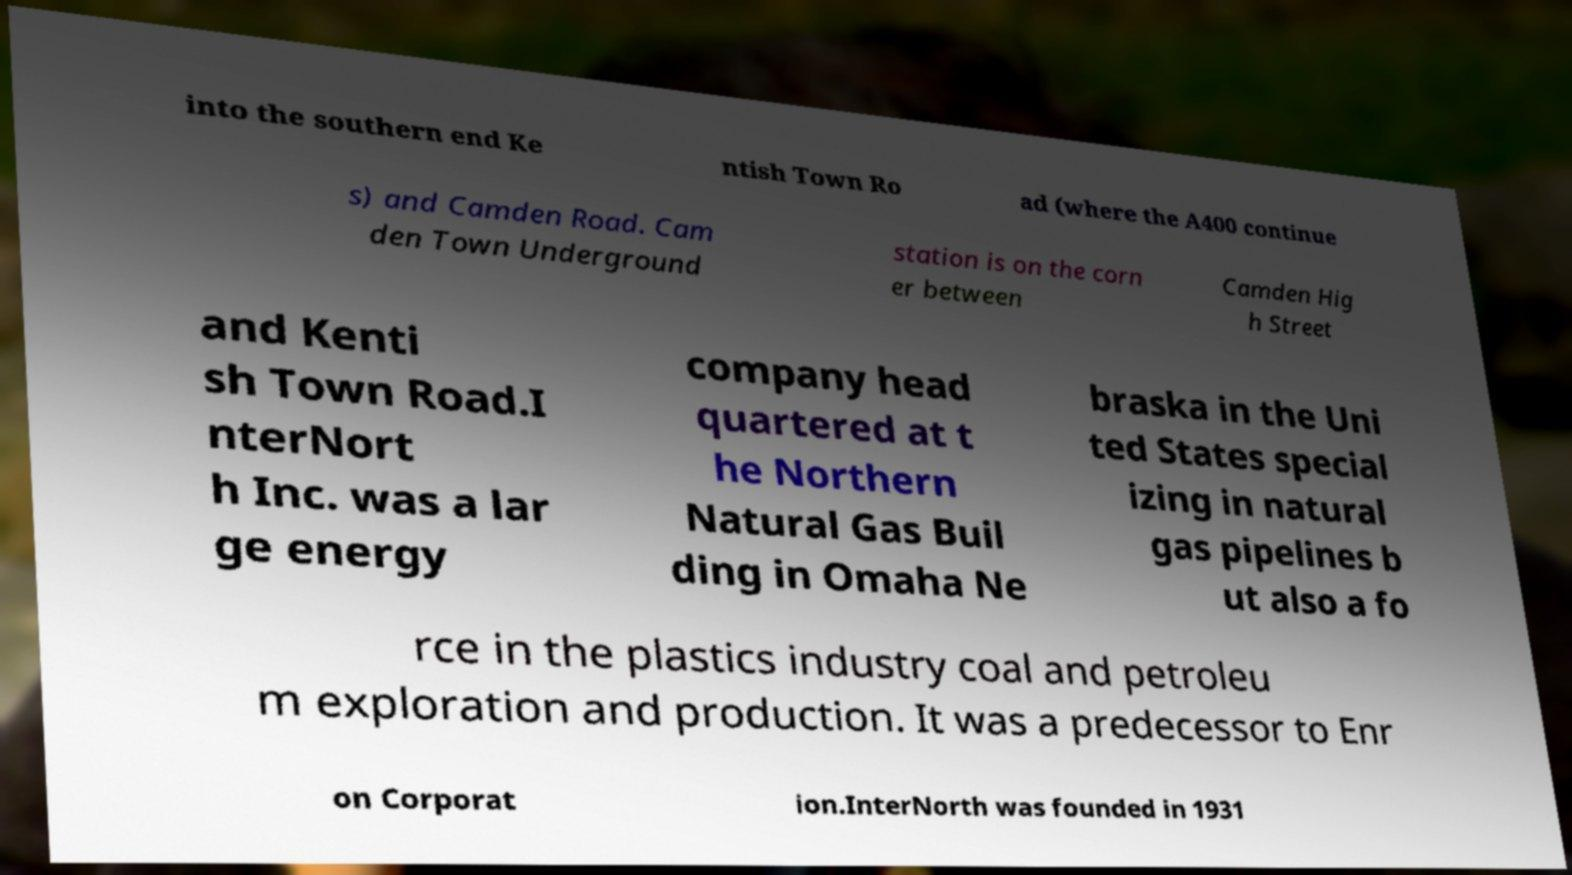Can you accurately transcribe the text from the provided image for me? into the southern end Ke ntish Town Ro ad (where the A400 continue s) and Camden Road. Cam den Town Underground station is on the corn er between Camden Hig h Street and Kenti sh Town Road.I nterNort h Inc. was a lar ge energy company head quartered at t he Northern Natural Gas Buil ding in Omaha Ne braska in the Uni ted States special izing in natural gas pipelines b ut also a fo rce in the plastics industry coal and petroleu m exploration and production. It was a predecessor to Enr on Corporat ion.InterNorth was founded in 1931 